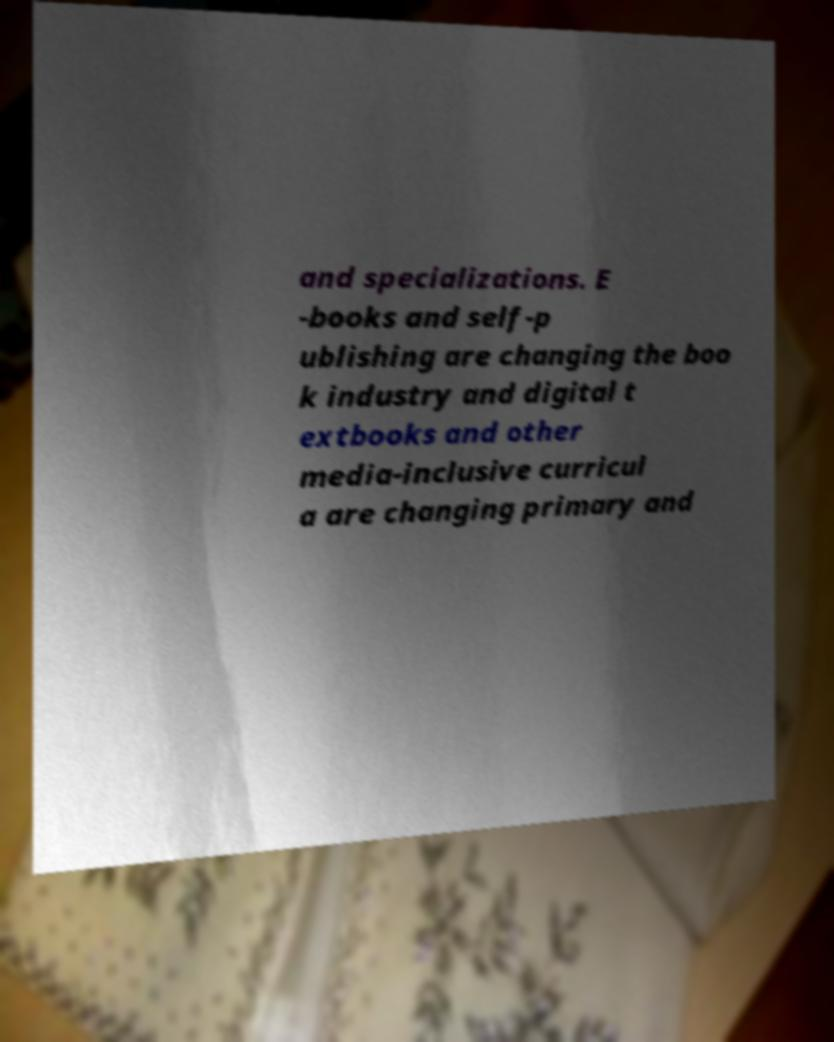Can you accurately transcribe the text from the provided image for me? and specializations. E -books and self-p ublishing are changing the boo k industry and digital t extbooks and other media-inclusive curricul a are changing primary and 